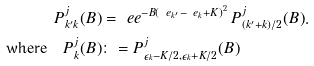<formula> <loc_0><loc_0><loc_500><loc_500>P _ { k ^ { \prime } k } ^ { j } ( B ) & = \ e e ^ { - B \left ( \ e _ { k ^ { \prime } } - \ e _ { k } + K \right ) ^ { 2 } } \, P _ { ( k ^ { \prime } + k ) / 2 } ^ { j } ( B ) . \\ \text {where} \quad P _ { k } ^ { j } ( B ) & \colon = P _ { \epsilon _ { k } - K / 2 , \epsilon _ { k } + K / 2 } ^ { j } ( B )</formula> 